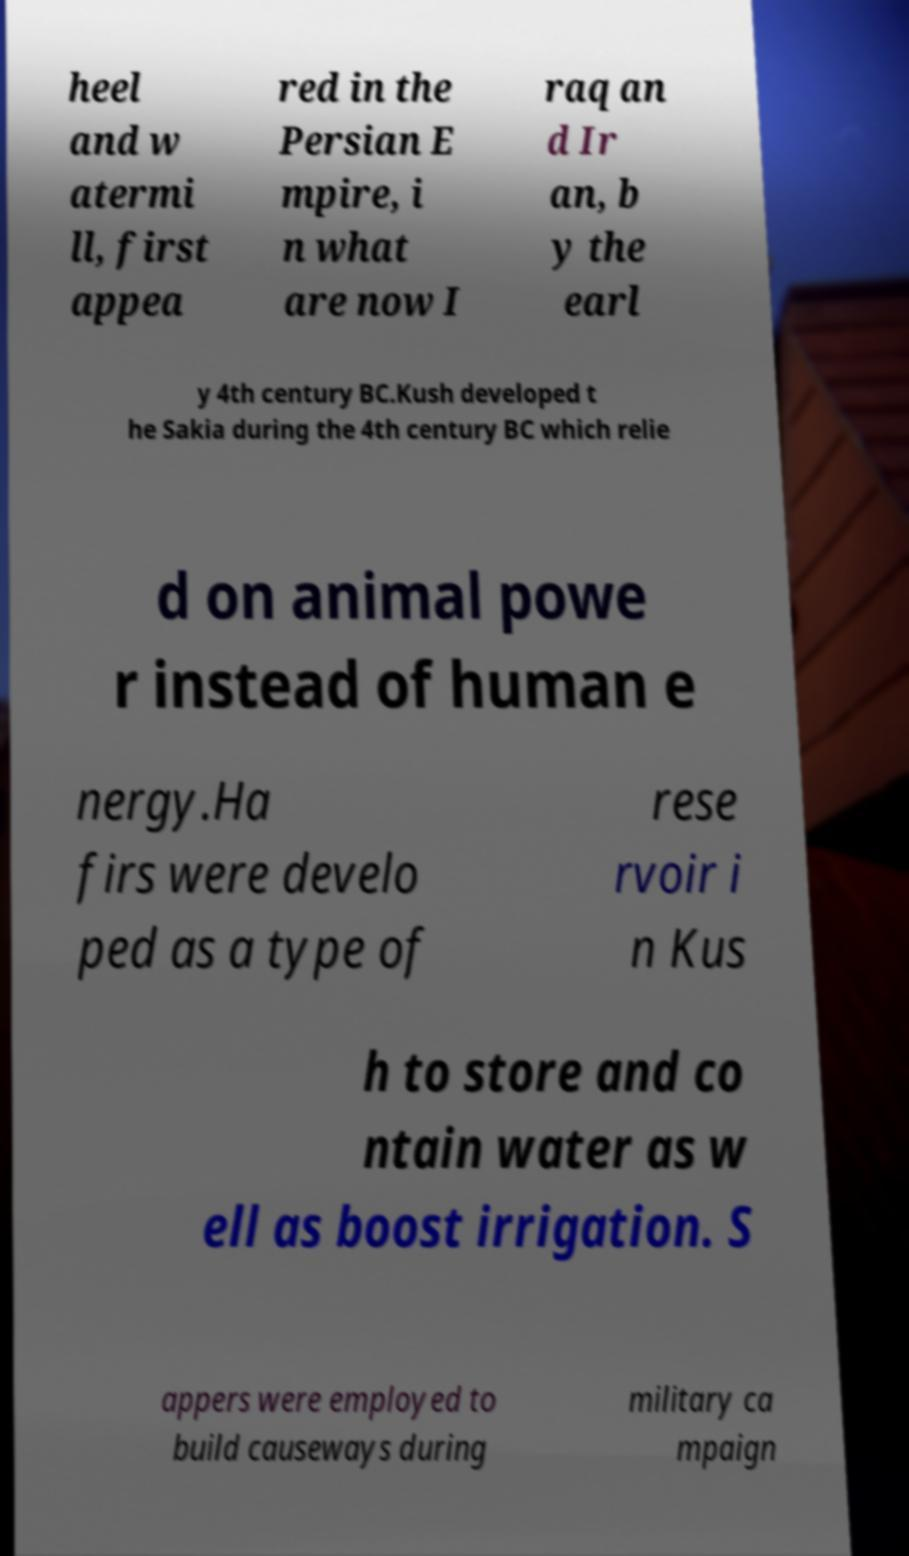I need the written content from this picture converted into text. Can you do that? heel and w atermi ll, first appea red in the Persian E mpire, i n what are now I raq an d Ir an, b y the earl y 4th century BC.Kush developed t he Sakia during the 4th century BC which relie d on animal powe r instead of human e nergy.Ha firs were develo ped as a type of rese rvoir i n Kus h to store and co ntain water as w ell as boost irrigation. S appers were employed to build causeways during military ca mpaign 